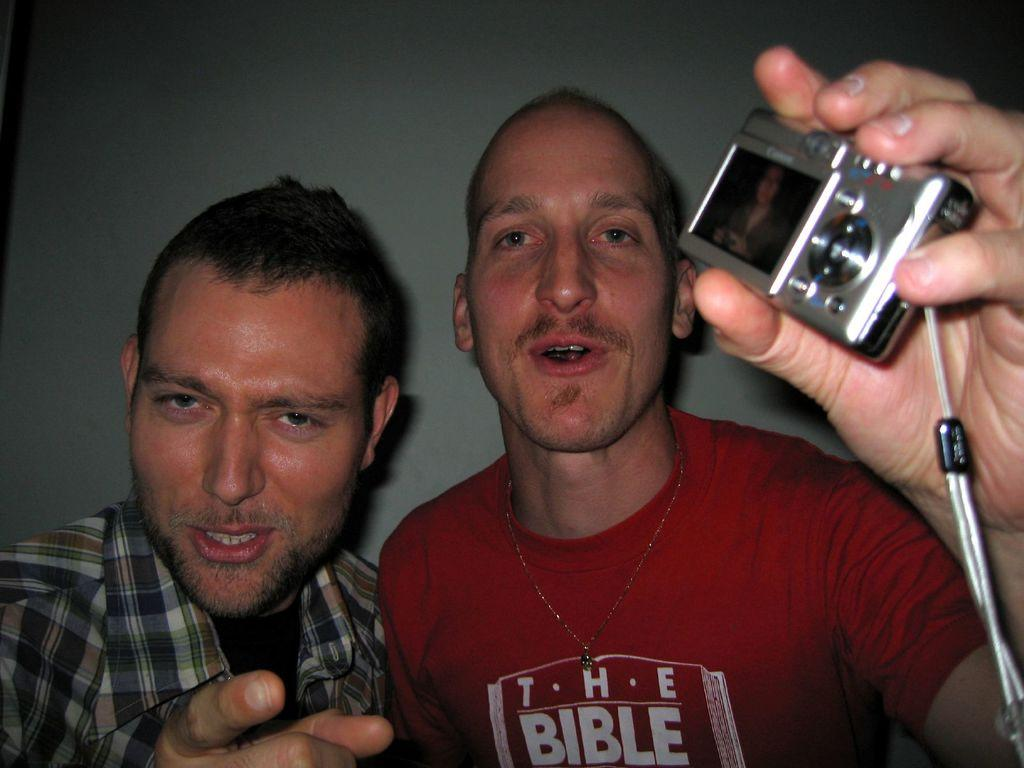What is the man on the left side of the image wearing? The man on the left side of the image is wearing a shirt. What is the man on the right side of the image wearing? The man on the right side of the image is wearing a red t-shirt. What is the man in the red t-shirt holding in his hands? The man in the red t-shirt is holding a camera in his hands. What type of trouble is the man in the red t-shirt experiencing while on holiday? There is no indication of trouble or a holiday in the image; it simply shows two men, one of whom is holding a camera. 